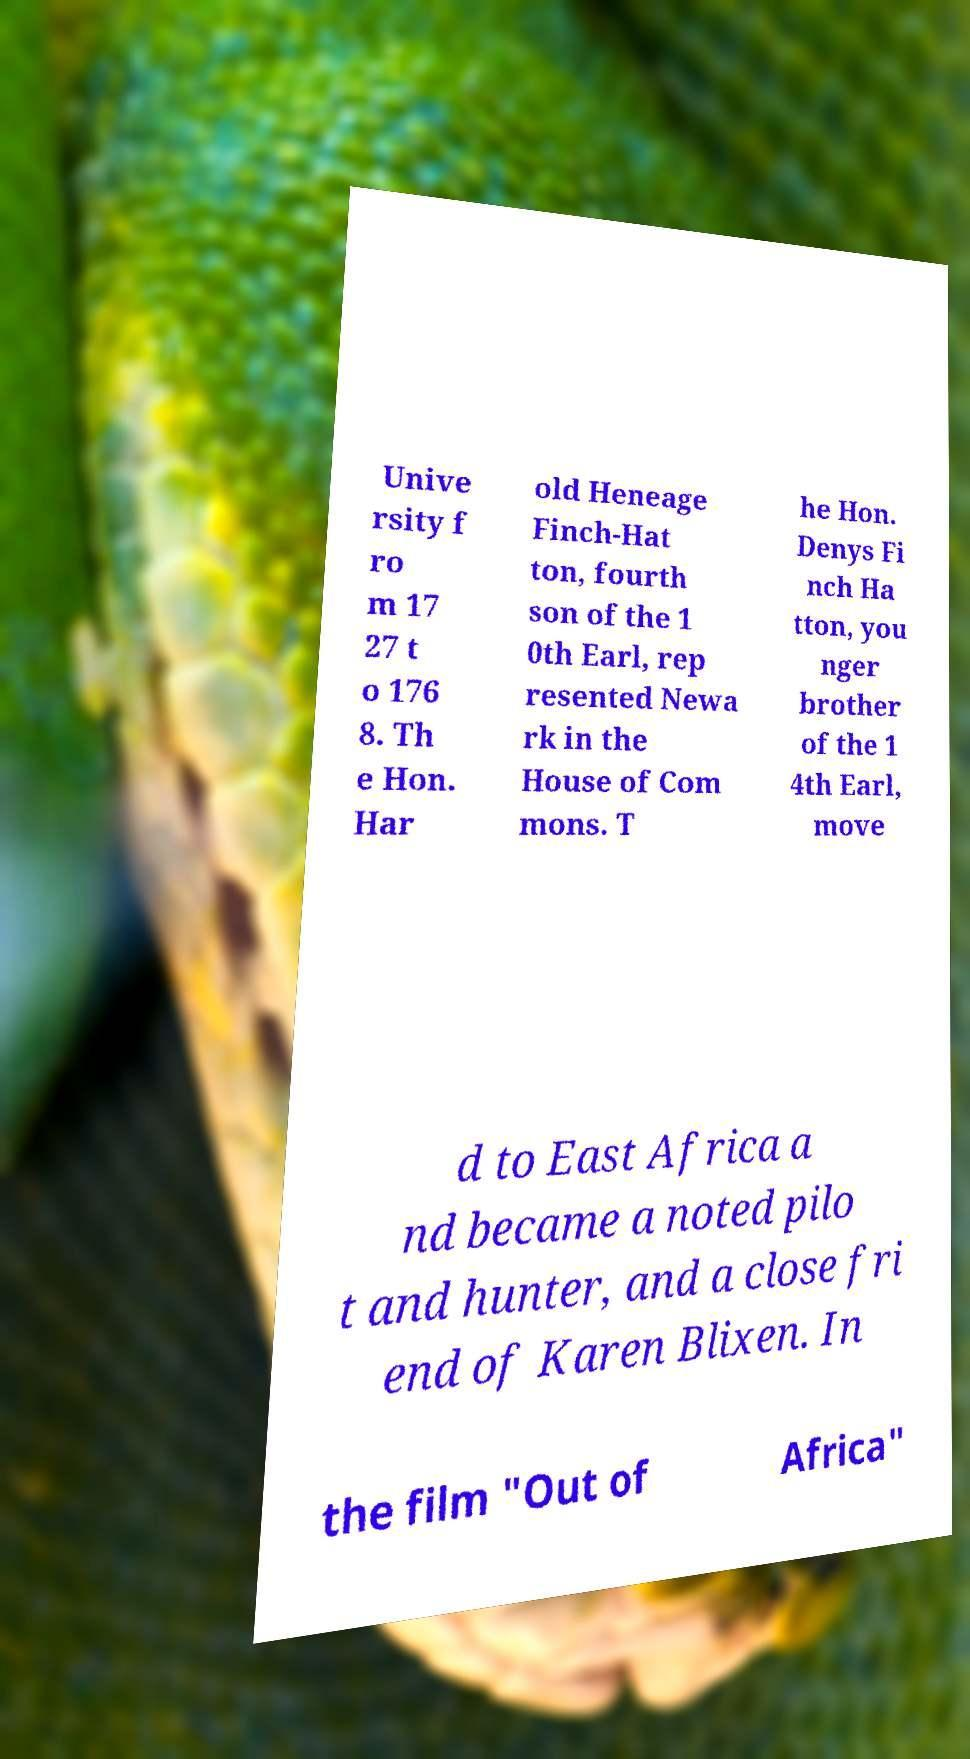What messages or text are displayed in this image? I need them in a readable, typed format. Unive rsity f ro m 17 27 t o 176 8. Th e Hon. Har old Heneage Finch-Hat ton, fourth son of the 1 0th Earl, rep resented Newa rk in the House of Com mons. T he Hon. Denys Fi nch Ha tton, you nger brother of the 1 4th Earl, move d to East Africa a nd became a noted pilo t and hunter, and a close fri end of Karen Blixen. In the film "Out of Africa" 